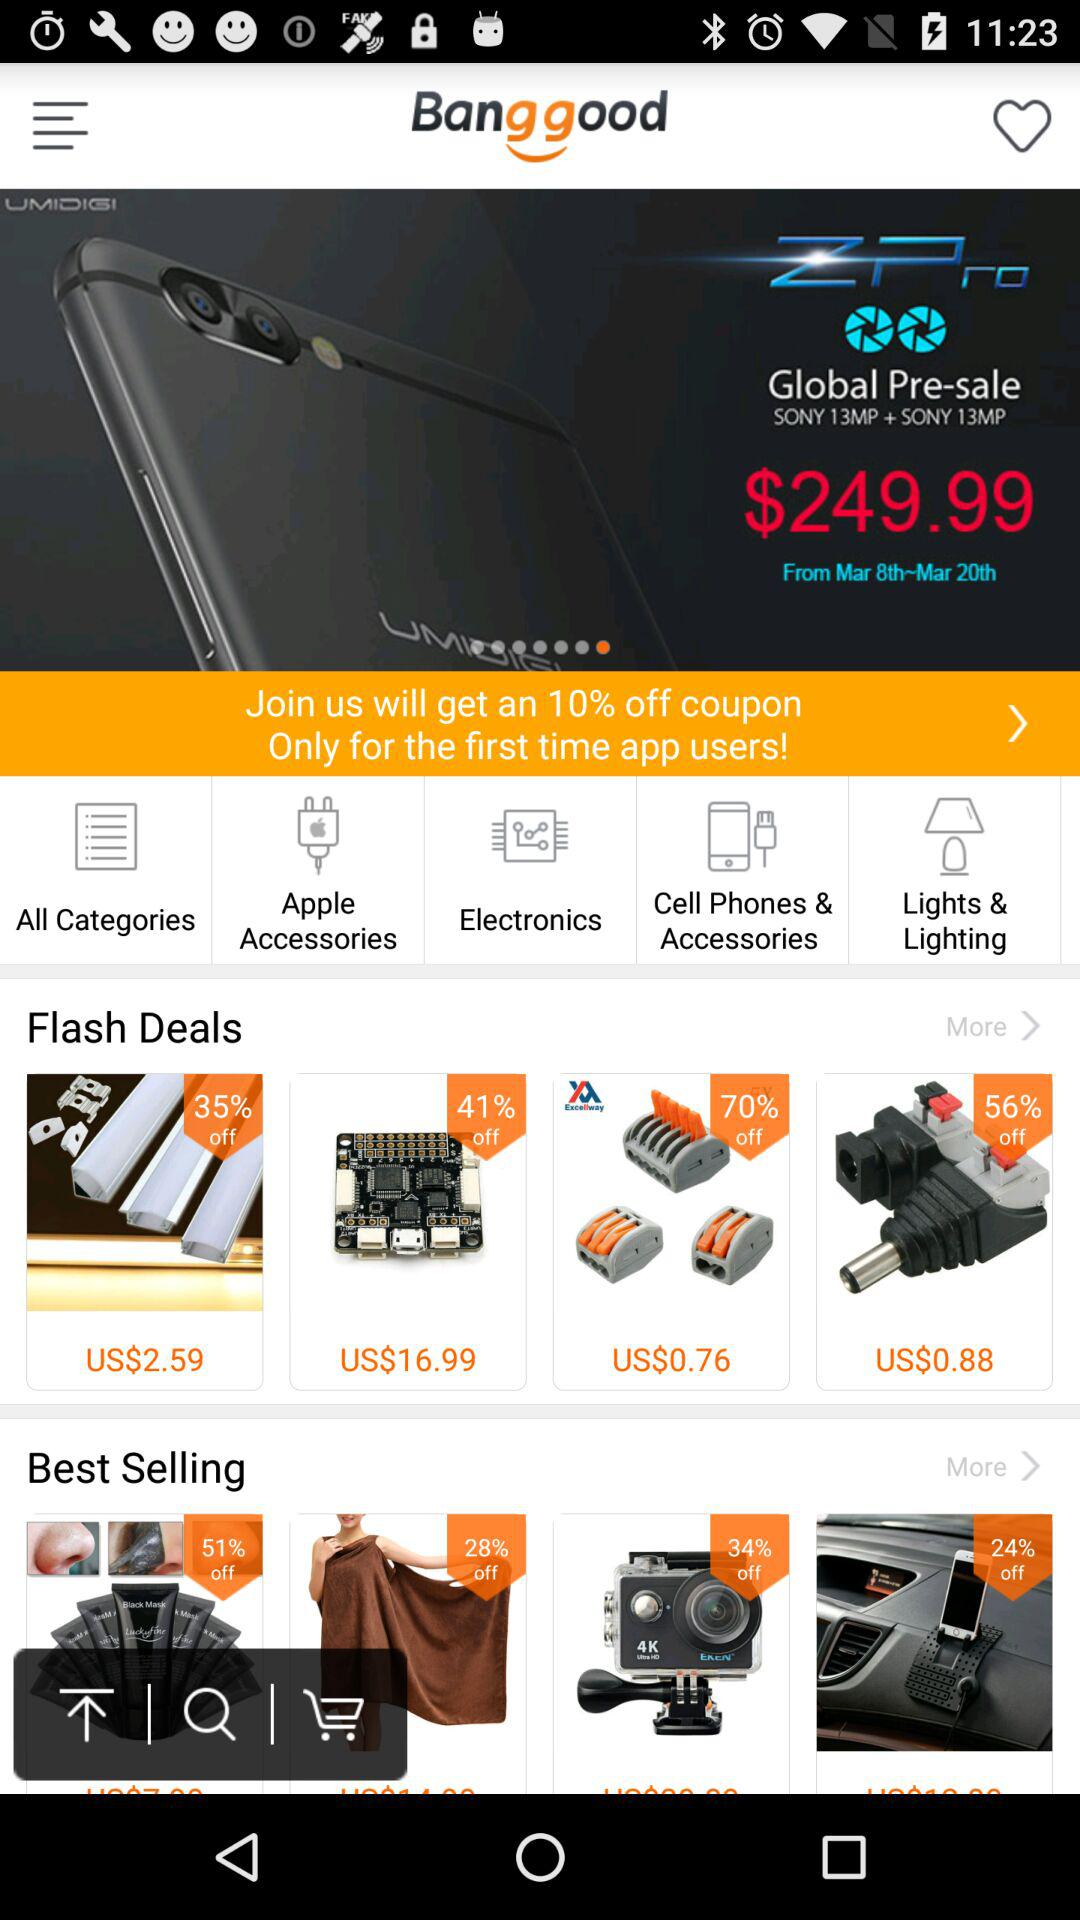What is the price of "Z Pro"? The price is $249.99. 